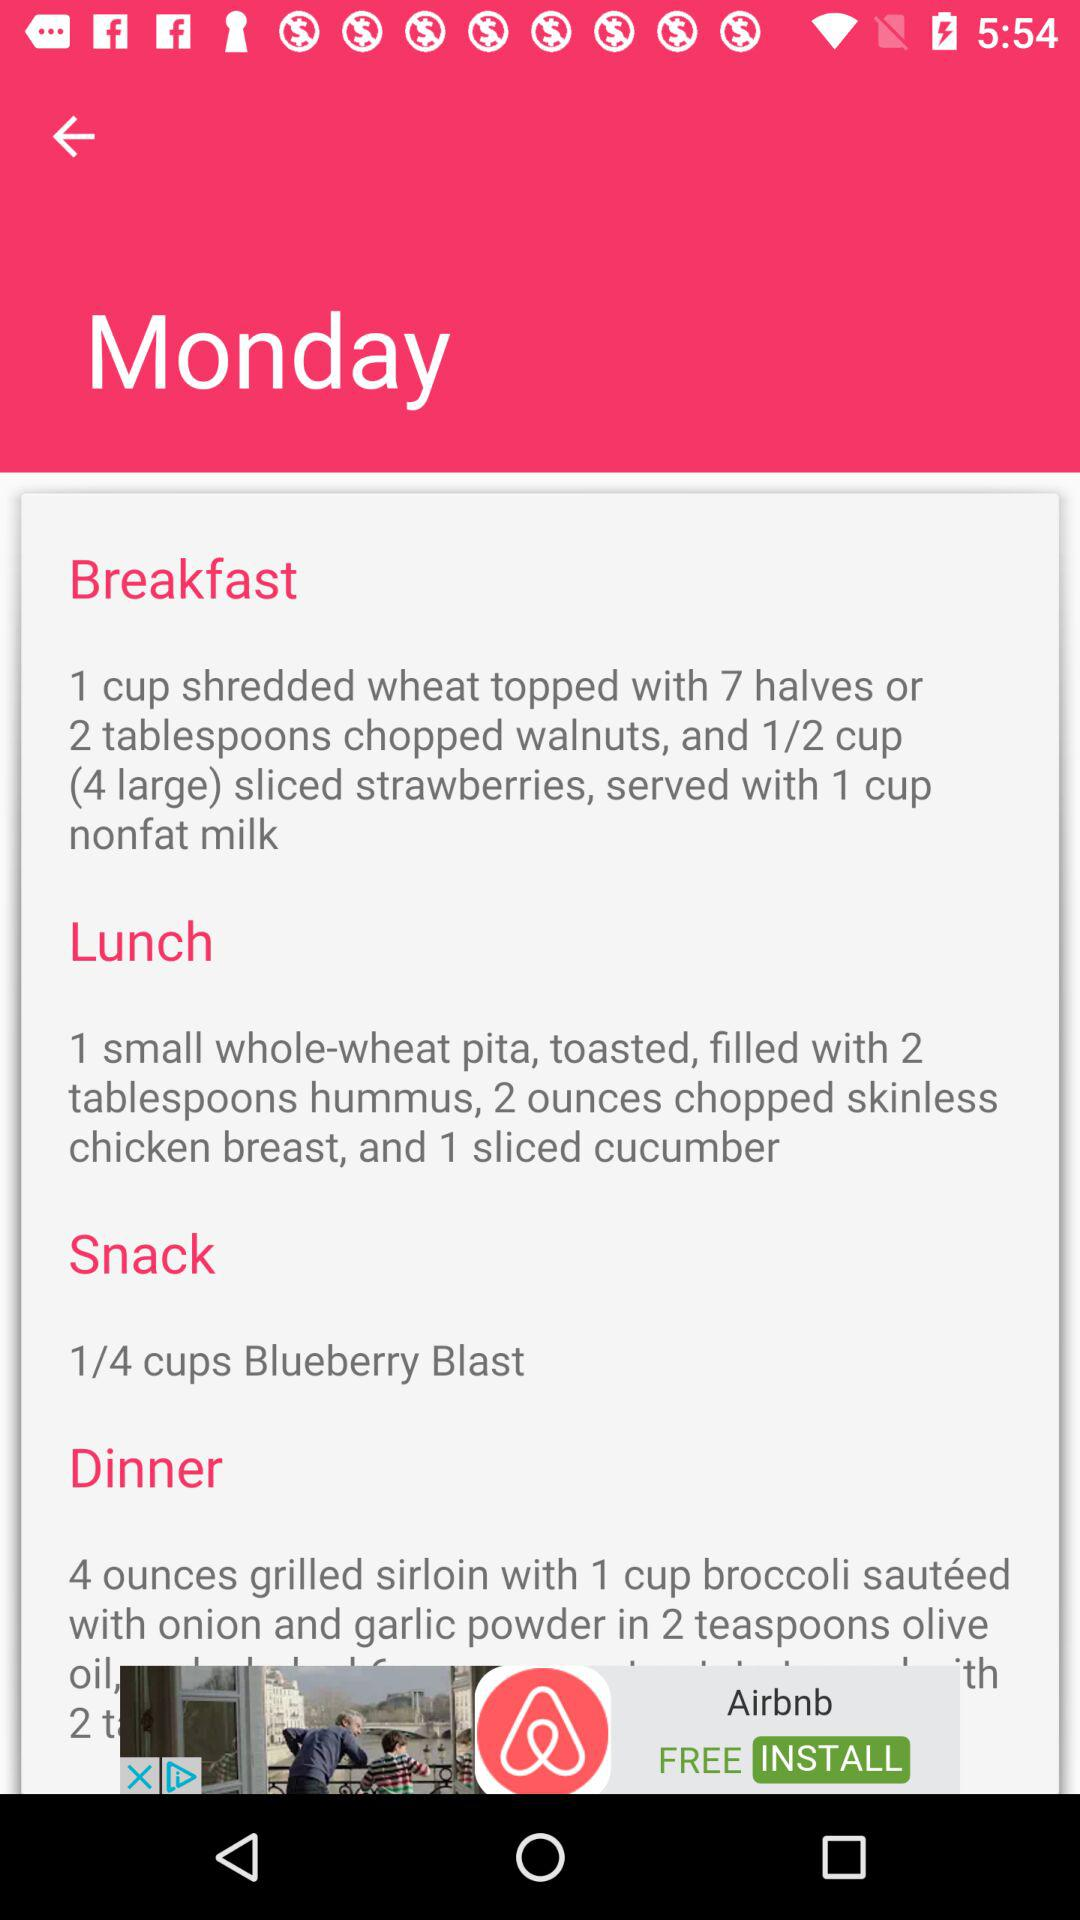What's in the snack? There is 1/4 cup of Blueberry Blast in the snack. 